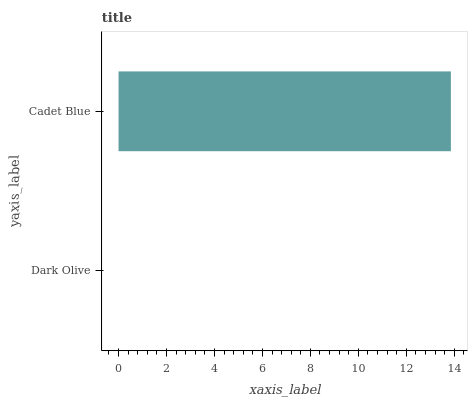Is Dark Olive the minimum?
Answer yes or no. Yes. Is Cadet Blue the maximum?
Answer yes or no. Yes. Is Cadet Blue the minimum?
Answer yes or no. No. Is Cadet Blue greater than Dark Olive?
Answer yes or no. Yes. Is Dark Olive less than Cadet Blue?
Answer yes or no. Yes. Is Dark Olive greater than Cadet Blue?
Answer yes or no. No. Is Cadet Blue less than Dark Olive?
Answer yes or no. No. Is Cadet Blue the high median?
Answer yes or no. Yes. Is Dark Olive the low median?
Answer yes or no. Yes. Is Dark Olive the high median?
Answer yes or no. No. Is Cadet Blue the low median?
Answer yes or no. No. 